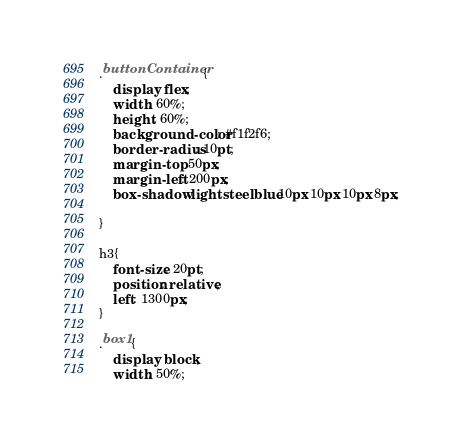<code> <loc_0><loc_0><loc_500><loc_500><_CSS_>.buttonContainer{
    display: flex;
    width: 60%;
    height: 60%;
    background-color: #f1f2f6;
    border-radius: 10pt;
    margin-top: 50px;
    margin-left: 200px;
    box-shadow: lightsteelblue 10px 10px 10px 8px;
    
}

h3{
    font-size: 20pt;
    position: relative;
    left: 1300px;
}

.box1{
    display: block;
    width: 50%;</code> 